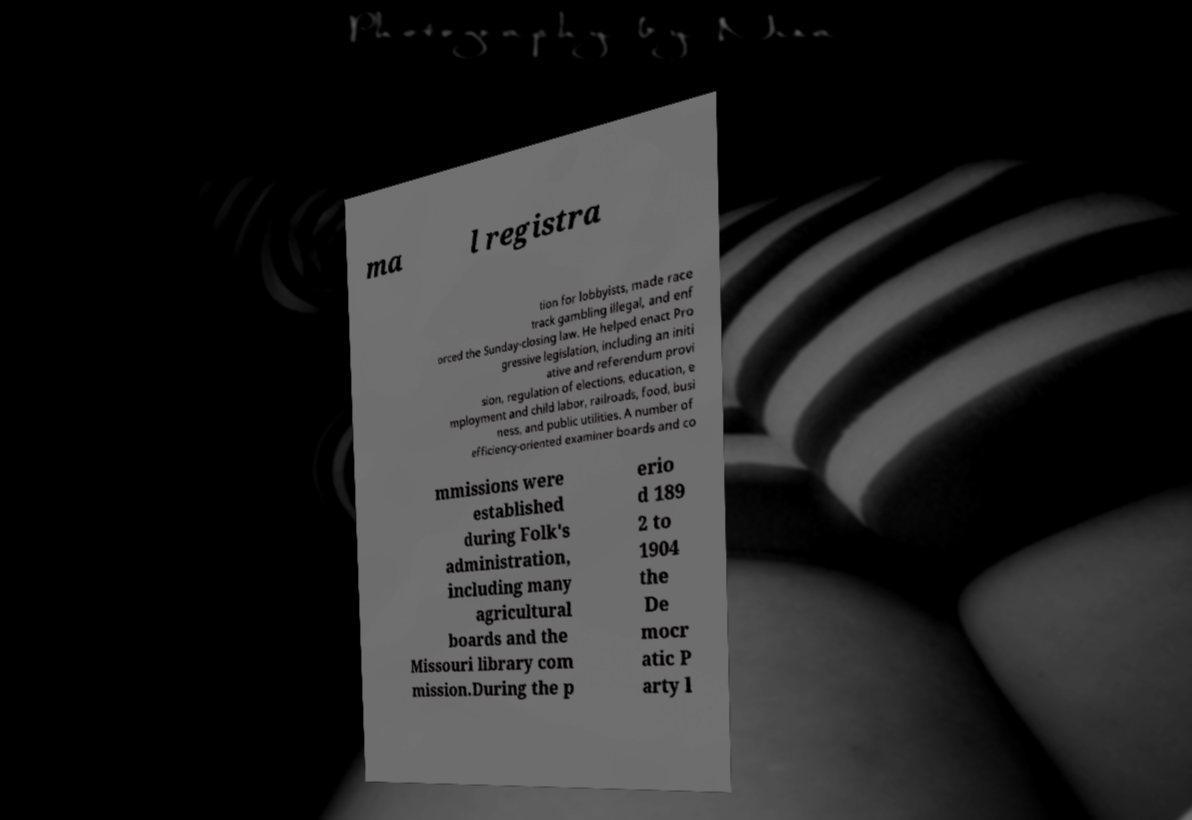Can you read and provide the text displayed in the image?This photo seems to have some interesting text. Can you extract and type it out for me? ma l registra tion for lobbyists, made race track gambling illegal, and enf orced the Sunday-closing law. He helped enact Pro gressive legislation, including an initi ative and referendum provi sion, regulation of elections, education, e mployment and child labor, railroads, food, busi ness, and public utilities. A number of efficiency-oriented examiner boards and co mmissions were established during Folk's administration, including many agricultural boards and the Missouri library com mission.During the p erio d 189 2 to 1904 the De mocr atic P arty l 